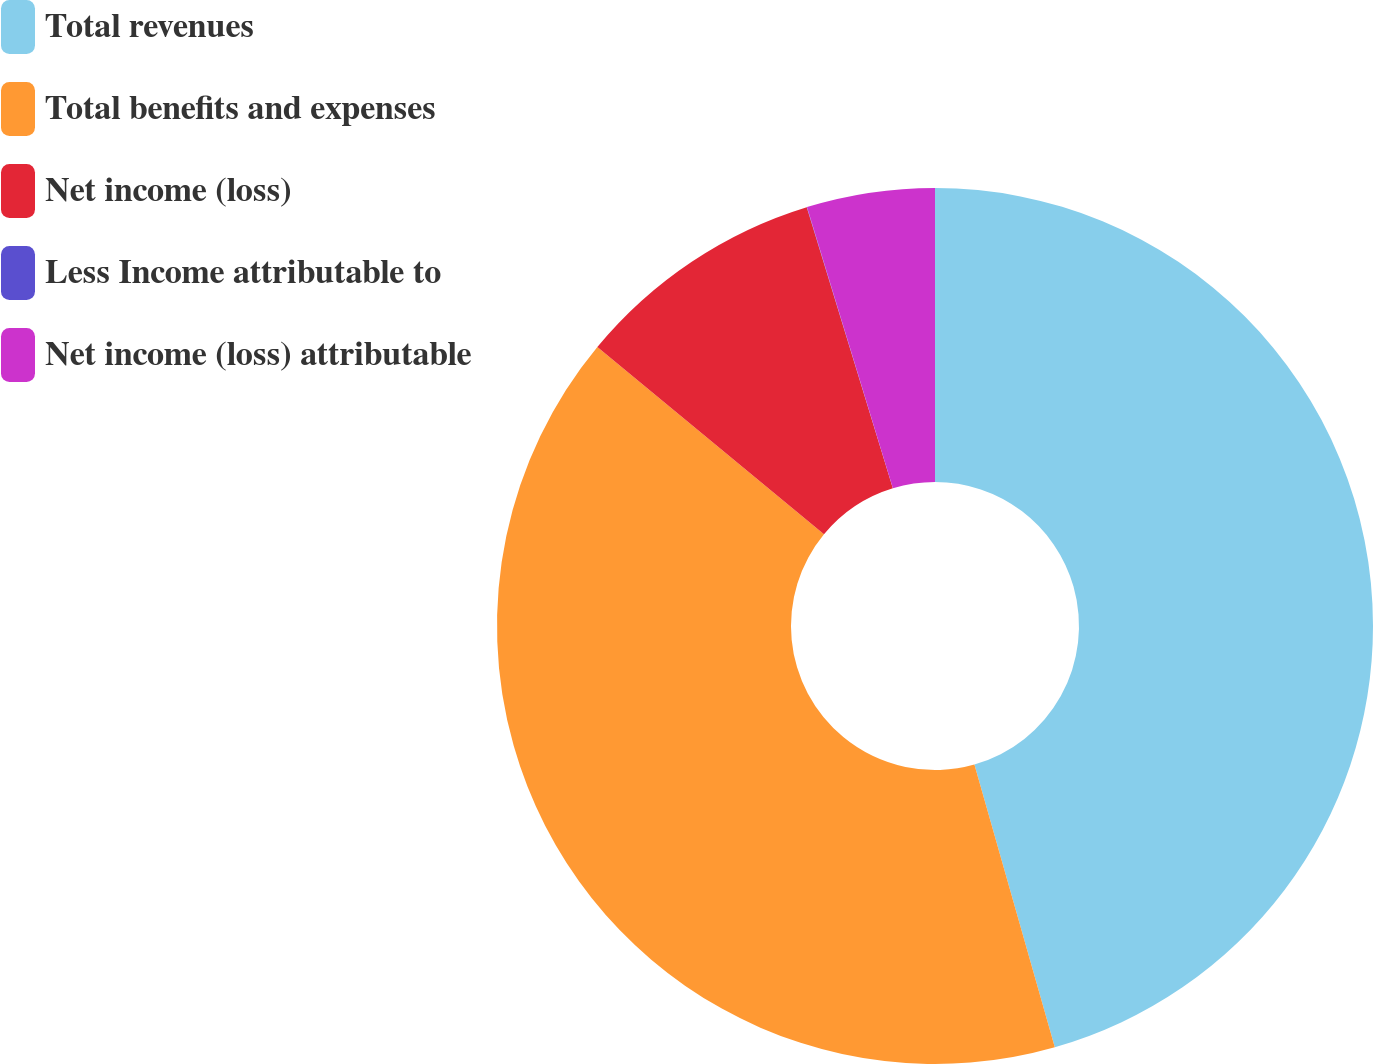<chart> <loc_0><loc_0><loc_500><loc_500><pie_chart><fcel>Total revenues<fcel>Total benefits and expenses<fcel>Net income (loss)<fcel>Less Income attributable to<fcel>Net income (loss) attributable<nl><fcel>45.59%<fcel>40.4%<fcel>9.28%<fcel>0.01%<fcel>4.72%<nl></chart> 